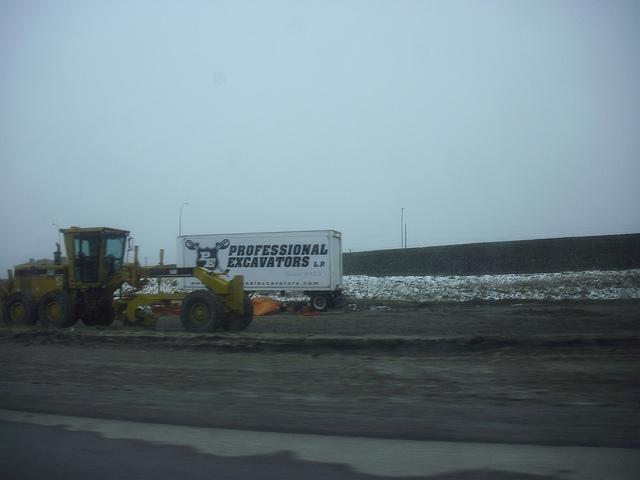How many trains are pictured?
Give a very brief answer. 0. How many trucks are there?
Give a very brief answer. 2. 